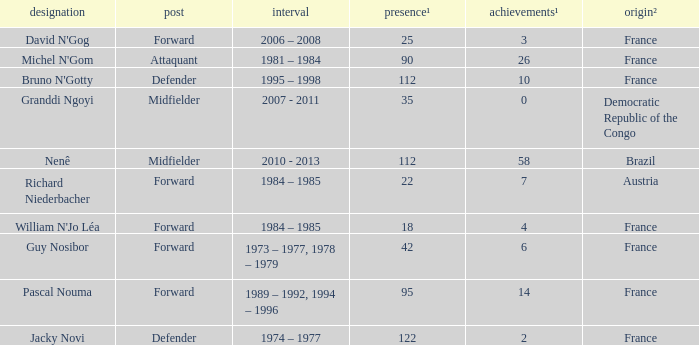List the number of active years for attaquant. 1981 – 1984. 